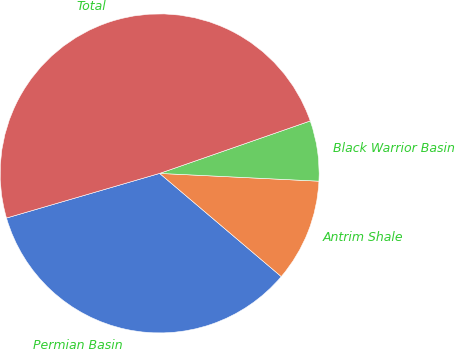Convert chart. <chart><loc_0><loc_0><loc_500><loc_500><pie_chart><fcel>Permian Basin<fcel>Antrim Shale<fcel>Black Warrior Basin<fcel>Total<nl><fcel>34.29%<fcel>10.42%<fcel>6.11%<fcel>49.18%<nl></chart> 